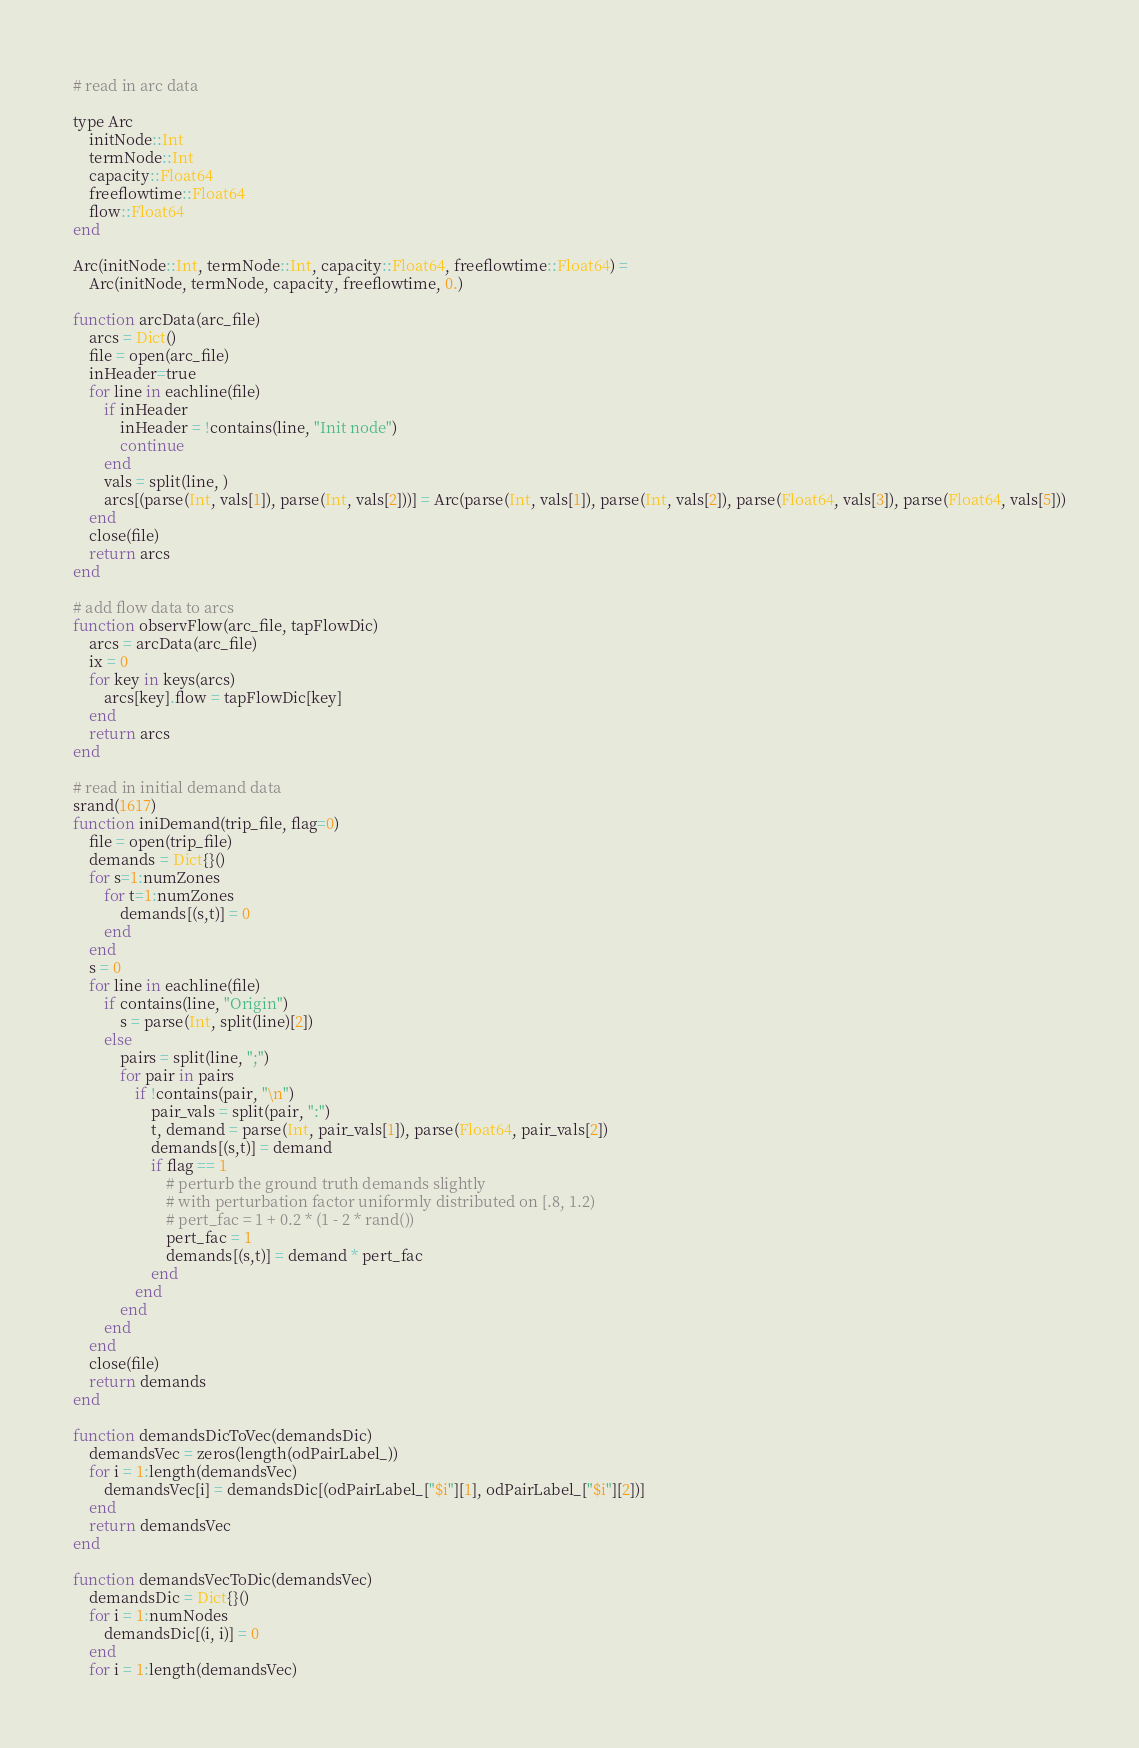<code> <loc_0><loc_0><loc_500><loc_500><_Julia_># read in arc data

type Arc
    initNode::Int 
    termNode::Int 
    capacity::Float64
    freeflowtime::Float64
    flow::Float64
end

Arc(initNode::Int, termNode::Int, capacity::Float64, freeflowtime::Float64) = 
    Arc(initNode, termNode, capacity, freeflowtime, 0.)

function arcData(arc_file)
    arcs = Dict()
    file = open(arc_file)
    inHeader=true
    for line in eachline(file)
        if inHeader
            inHeader = !contains(line, "Init node")
            continue
        end
        vals = split(line, )
        arcs[(parse(Int, vals[1]), parse(Int, vals[2]))] = Arc(parse(Int, vals[1]), parse(Int, vals[2]), parse(Float64, vals[3]), parse(Float64, vals[5]))
    end
    close(file) 
    return arcs
end

# add flow data to arcs
function observFlow(arc_file, tapFlowDic)
    arcs = arcData(arc_file)
    ix = 0 
    for key in keys(arcs)
        arcs[key].flow = tapFlowDic[key]
    end
    return arcs
end

# read in initial demand data
srand(1617)
function iniDemand(trip_file, flag=0)
    file = open(trip_file)
    demands = Dict{}()
    for s=1:numZones
        for t=1:numZones
            demands[(s,t)] = 0
        end
    end    
    s = 0
    for line in eachline(file)
        if contains(line, "Origin")
            s = parse(Int, split(line)[2])
        else
            pairs = split(line, ";")
            for pair in pairs
                if !contains(pair, "\n")
                    pair_vals = split(pair, ":")
                    t, demand = parse(Int, pair_vals[1]), parse(Float64, pair_vals[2])
                    demands[(s,t)] = demand
                    if flag == 1
                        # perturb the ground truth demands slightly 
                        # with perturbation factor uniformly distributed on [.8, 1.2)
                        # pert_fac = 1 + 0.2 * (1 - 2 * rand())
                        pert_fac = 1
                        demands[(s,t)] = demand * pert_fac
                    end
                end
            end
        end
    end            
    close(file)
    return demands
end

function demandsDicToVec(demandsDic)
    demandsVec = zeros(length(odPairLabel_))
    for i = 1:length(demandsVec)
        demandsVec[i] = demandsDic[(odPairLabel_["$i"][1], odPairLabel_["$i"][2])]
    end
    return demandsVec
end

function demandsVecToDic(demandsVec)
    demandsDic = Dict{}()
    for i = 1:numNodes
        demandsDic[(i, i)] = 0
    end
    for i = 1:length(demandsVec)</code> 